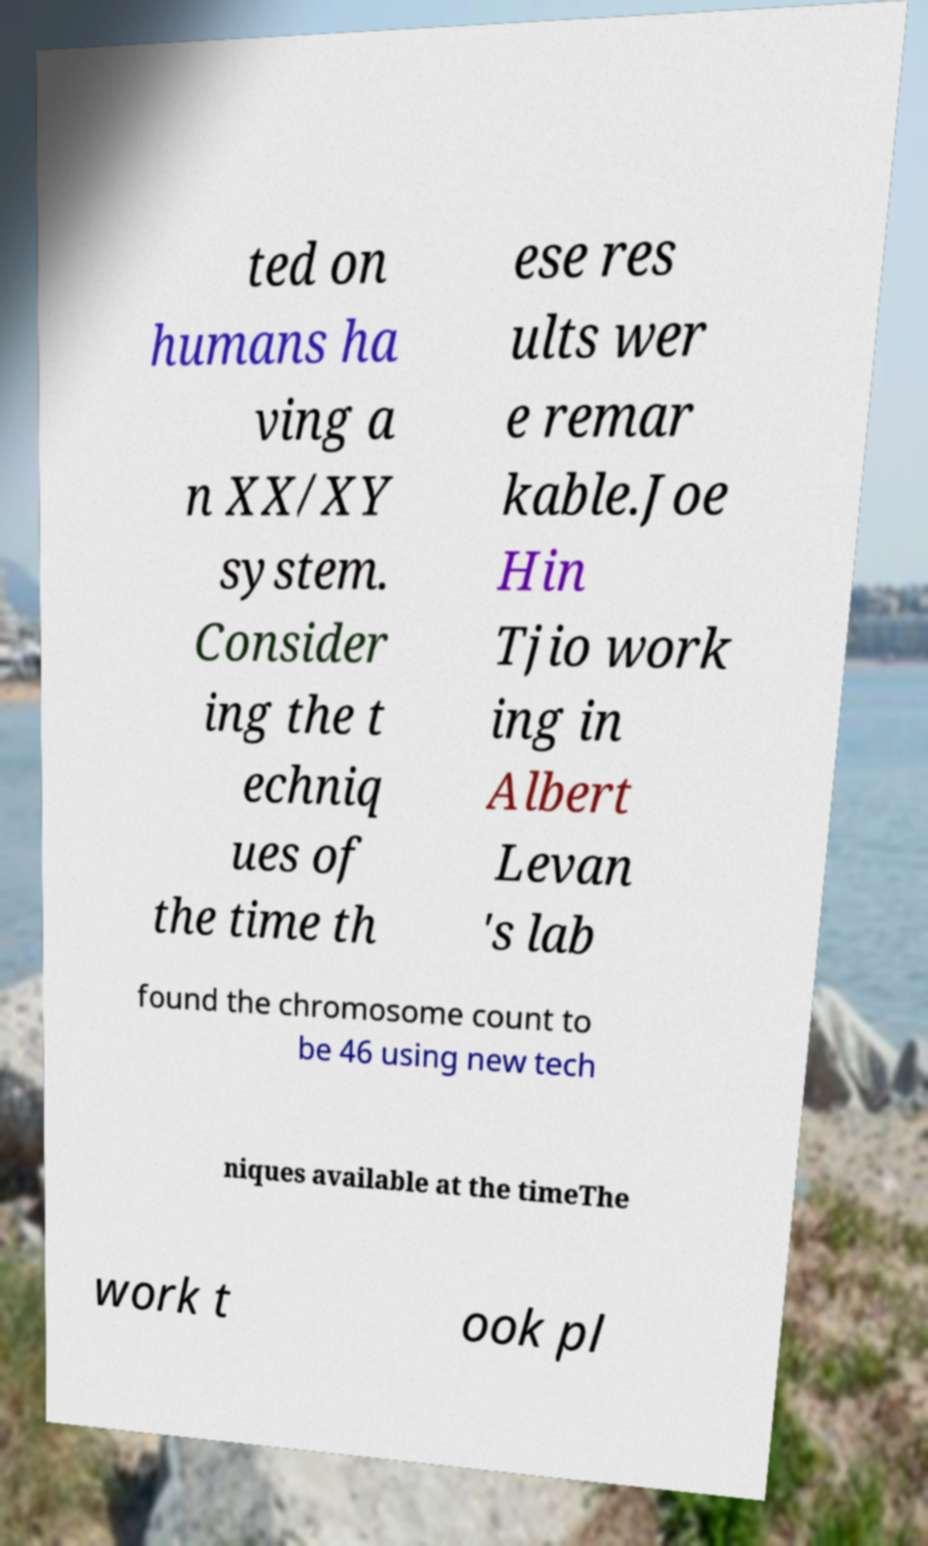Could you assist in decoding the text presented in this image and type it out clearly? ted on humans ha ving a n XX/XY system. Consider ing the t echniq ues of the time th ese res ults wer e remar kable.Joe Hin Tjio work ing in Albert Levan 's lab found the chromosome count to be 46 using new tech niques available at the timeThe work t ook pl 